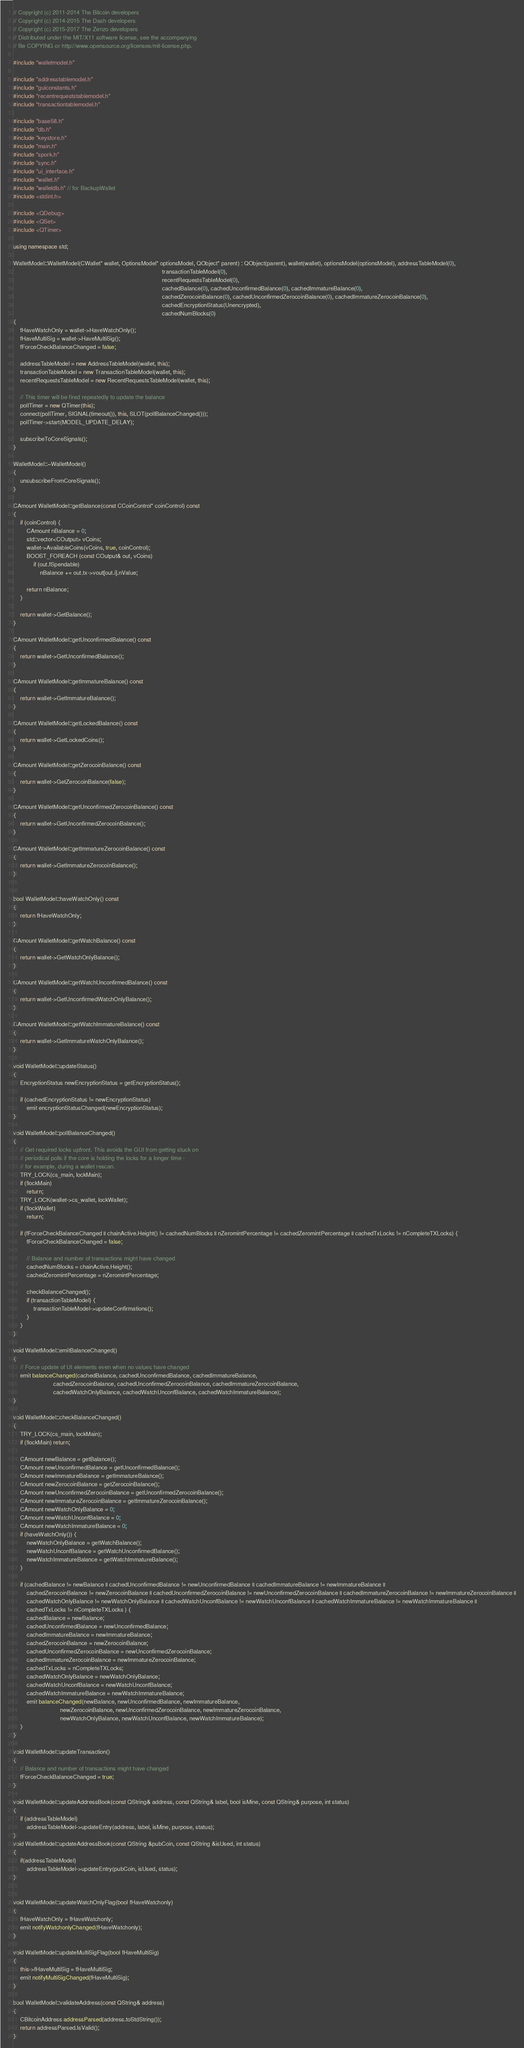<code> <loc_0><loc_0><loc_500><loc_500><_C++_>// Copyright (c) 2011-2014 The Bitcoin developers
// Copyright (c) 2014-2015 The Dash developers
// Copyright (c) 2015-2017 The Zenzo developers
// Distributed under the MIT/X11 software license, see the accompanying
// file COPYING or http://www.opensource.org/licenses/mit-license.php.

#include "walletmodel.h"

#include "addresstablemodel.h"
#include "guiconstants.h"
#include "recentrequeststablemodel.h"
#include "transactiontablemodel.h"

#include "base58.h"
#include "db.h"
#include "keystore.h"
#include "main.h"
#include "spork.h"
#include "sync.h"
#include "ui_interface.h"
#include "wallet.h"
#include "walletdb.h" // for BackupWallet
#include <stdint.h>

#include <QDebug>
#include <QSet>
#include <QTimer>

using namespace std;

WalletModel::WalletModel(CWallet* wallet, OptionsModel* optionsModel, QObject* parent) : QObject(parent), wallet(wallet), optionsModel(optionsModel), addressTableModel(0),
                                                                                         transactionTableModel(0),
                                                                                         recentRequestsTableModel(0),
                                                                                         cachedBalance(0), cachedUnconfirmedBalance(0), cachedImmatureBalance(0),
                                                                                         cachedZerocoinBalance(0), cachedUnconfirmedZerocoinBalance(0), cachedImmatureZerocoinBalance(0),
                                                                                         cachedEncryptionStatus(Unencrypted),
                                                                                         cachedNumBlocks(0)
{
    fHaveWatchOnly = wallet->HaveWatchOnly();
    fHaveMultiSig = wallet->HaveMultiSig();
    fForceCheckBalanceChanged = false;

    addressTableModel = new AddressTableModel(wallet, this);
    transactionTableModel = new TransactionTableModel(wallet, this);
    recentRequestsTableModel = new RecentRequestsTableModel(wallet, this);

    // This timer will be fired repeatedly to update the balance
    pollTimer = new QTimer(this);
    connect(pollTimer, SIGNAL(timeout()), this, SLOT(pollBalanceChanged()));
    pollTimer->start(MODEL_UPDATE_DELAY);

    subscribeToCoreSignals();
}

WalletModel::~WalletModel()
{
    unsubscribeFromCoreSignals();
}

CAmount WalletModel::getBalance(const CCoinControl* coinControl) const
{
    if (coinControl) {
        CAmount nBalance = 0;
        std::vector<COutput> vCoins;
        wallet->AvailableCoins(vCoins, true, coinControl);
        BOOST_FOREACH (const COutput& out, vCoins)
            if (out.fSpendable)
                nBalance += out.tx->vout[out.i].nValue;

        return nBalance;
    }

    return wallet->GetBalance();
}

CAmount WalletModel::getUnconfirmedBalance() const
{
    return wallet->GetUnconfirmedBalance();
}

CAmount WalletModel::getImmatureBalance() const
{
    return wallet->GetImmatureBalance();
}

CAmount WalletModel::getLockedBalance() const
{
    return wallet->GetLockedCoins();
}

CAmount WalletModel::getZerocoinBalance() const
{
    return wallet->GetZerocoinBalance(false);
}

CAmount WalletModel::getUnconfirmedZerocoinBalance() const
{
    return wallet->GetUnconfirmedZerocoinBalance();
}

CAmount WalletModel::getImmatureZerocoinBalance() const
{
    return wallet->GetImmatureZerocoinBalance();
}


bool WalletModel::haveWatchOnly() const
{
    return fHaveWatchOnly;
}

CAmount WalletModel::getWatchBalance() const
{
    return wallet->GetWatchOnlyBalance();
}

CAmount WalletModel::getWatchUnconfirmedBalance() const
{
    return wallet->GetUnconfirmedWatchOnlyBalance();
}

CAmount WalletModel::getWatchImmatureBalance() const
{
    return wallet->GetImmatureWatchOnlyBalance();
}

void WalletModel::updateStatus()
{
    EncryptionStatus newEncryptionStatus = getEncryptionStatus();

    if (cachedEncryptionStatus != newEncryptionStatus)
        emit encryptionStatusChanged(newEncryptionStatus);
}

void WalletModel::pollBalanceChanged()
{
    // Get required locks upfront. This avoids the GUI from getting stuck on
    // periodical polls if the core is holding the locks for a longer time -
    // for example, during a wallet rescan.
    TRY_LOCK(cs_main, lockMain);
    if (!lockMain)
        return;
    TRY_LOCK(wallet->cs_wallet, lockWallet);
    if (!lockWallet)
        return;

    if (fForceCheckBalanceChanged || chainActive.Height() != cachedNumBlocks || nZeromintPercentage != cachedZeromintPercentage || cachedTxLocks != nCompleteTXLocks) {
        fForceCheckBalanceChanged = false;

        // Balance and number of transactions might have changed
        cachedNumBlocks = chainActive.Height();
        cachedZeromintPercentage = nZeromintPercentage;

        checkBalanceChanged();
        if (transactionTableModel) {
            transactionTableModel->updateConfirmations();
        }
    }
}

void WalletModel::emitBalanceChanged()
{
    // Force update of UI elements even when no values have changed
    emit balanceChanged(cachedBalance, cachedUnconfirmedBalance, cachedImmatureBalance, 
                        cachedZerocoinBalance, cachedUnconfirmedZerocoinBalance, cachedImmatureZerocoinBalance,
                        cachedWatchOnlyBalance, cachedWatchUnconfBalance, cachedWatchImmatureBalance);
}

void WalletModel::checkBalanceChanged()
{
    TRY_LOCK(cs_main, lockMain);
    if (!lockMain) return;

    CAmount newBalance = getBalance();
    CAmount newUnconfirmedBalance = getUnconfirmedBalance();
    CAmount newImmatureBalance = getImmatureBalance();
    CAmount newZerocoinBalance = getZerocoinBalance();
    CAmount newUnconfirmedZerocoinBalance = getUnconfirmedZerocoinBalance();
    CAmount newImmatureZerocoinBalance = getImmatureZerocoinBalance();
    CAmount newWatchOnlyBalance = 0;
    CAmount newWatchUnconfBalance = 0;
    CAmount newWatchImmatureBalance = 0;
    if (haveWatchOnly()) {
        newWatchOnlyBalance = getWatchBalance();
        newWatchUnconfBalance = getWatchUnconfirmedBalance();
        newWatchImmatureBalance = getWatchImmatureBalance();
    }

    if (cachedBalance != newBalance || cachedUnconfirmedBalance != newUnconfirmedBalance || cachedImmatureBalance != newImmatureBalance ||
        cachedZerocoinBalance != newZerocoinBalance || cachedUnconfirmedZerocoinBalance != newUnconfirmedZerocoinBalance || cachedImmatureZerocoinBalance != newImmatureZerocoinBalance ||
        cachedWatchOnlyBalance != newWatchOnlyBalance || cachedWatchUnconfBalance != newWatchUnconfBalance || cachedWatchImmatureBalance != newWatchImmatureBalance ||
        cachedTxLocks != nCompleteTXLocks ) {
        cachedBalance = newBalance;
        cachedUnconfirmedBalance = newUnconfirmedBalance;
        cachedImmatureBalance = newImmatureBalance;
        cachedZerocoinBalance = newZerocoinBalance;
        cachedUnconfirmedZerocoinBalance = newUnconfirmedZerocoinBalance;
        cachedImmatureZerocoinBalance = newImmatureZerocoinBalance;
        cachedTxLocks = nCompleteTXLocks;
        cachedWatchOnlyBalance = newWatchOnlyBalance;
        cachedWatchUnconfBalance = newWatchUnconfBalance;
        cachedWatchImmatureBalance = newWatchImmatureBalance;
        emit balanceChanged(newBalance, newUnconfirmedBalance, newImmatureBalance, 
                            newZerocoinBalance, newUnconfirmedZerocoinBalance, newImmatureZerocoinBalance,
                            newWatchOnlyBalance, newWatchUnconfBalance, newWatchImmatureBalance);
    }
}

void WalletModel::updateTransaction()
{
    // Balance and number of transactions might have changed
    fForceCheckBalanceChanged = true;
}

void WalletModel::updateAddressBook(const QString& address, const QString& label, bool isMine, const QString& purpose, int status)
{
    if (addressTableModel)
        addressTableModel->updateEntry(address, label, isMine, purpose, status);
}
void WalletModel::updateAddressBook(const QString &pubCoin, const QString &isUsed, int status)
{
    if(addressTableModel)
        addressTableModel->updateEntry(pubCoin, isUsed, status);
}


void WalletModel::updateWatchOnlyFlag(bool fHaveWatchonly)
{
    fHaveWatchOnly = fHaveWatchonly;
    emit notifyWatchonlyChanged(fHaveWatchonly);
}

void WalletModel::updateMultiSigFlag(bool fHaveMultiSig)
{
    this->fHaveMultiSig = fHaveMultiSig;
    emit notifyMultiSigChanged(fHaveMultiSig);
}

bool WalletModel::validateAddress(const QString& address)
{
    CBitcoinAddress addressParsed(address.toStdString());
    return addressParsed.IsValid();
}
</code> 